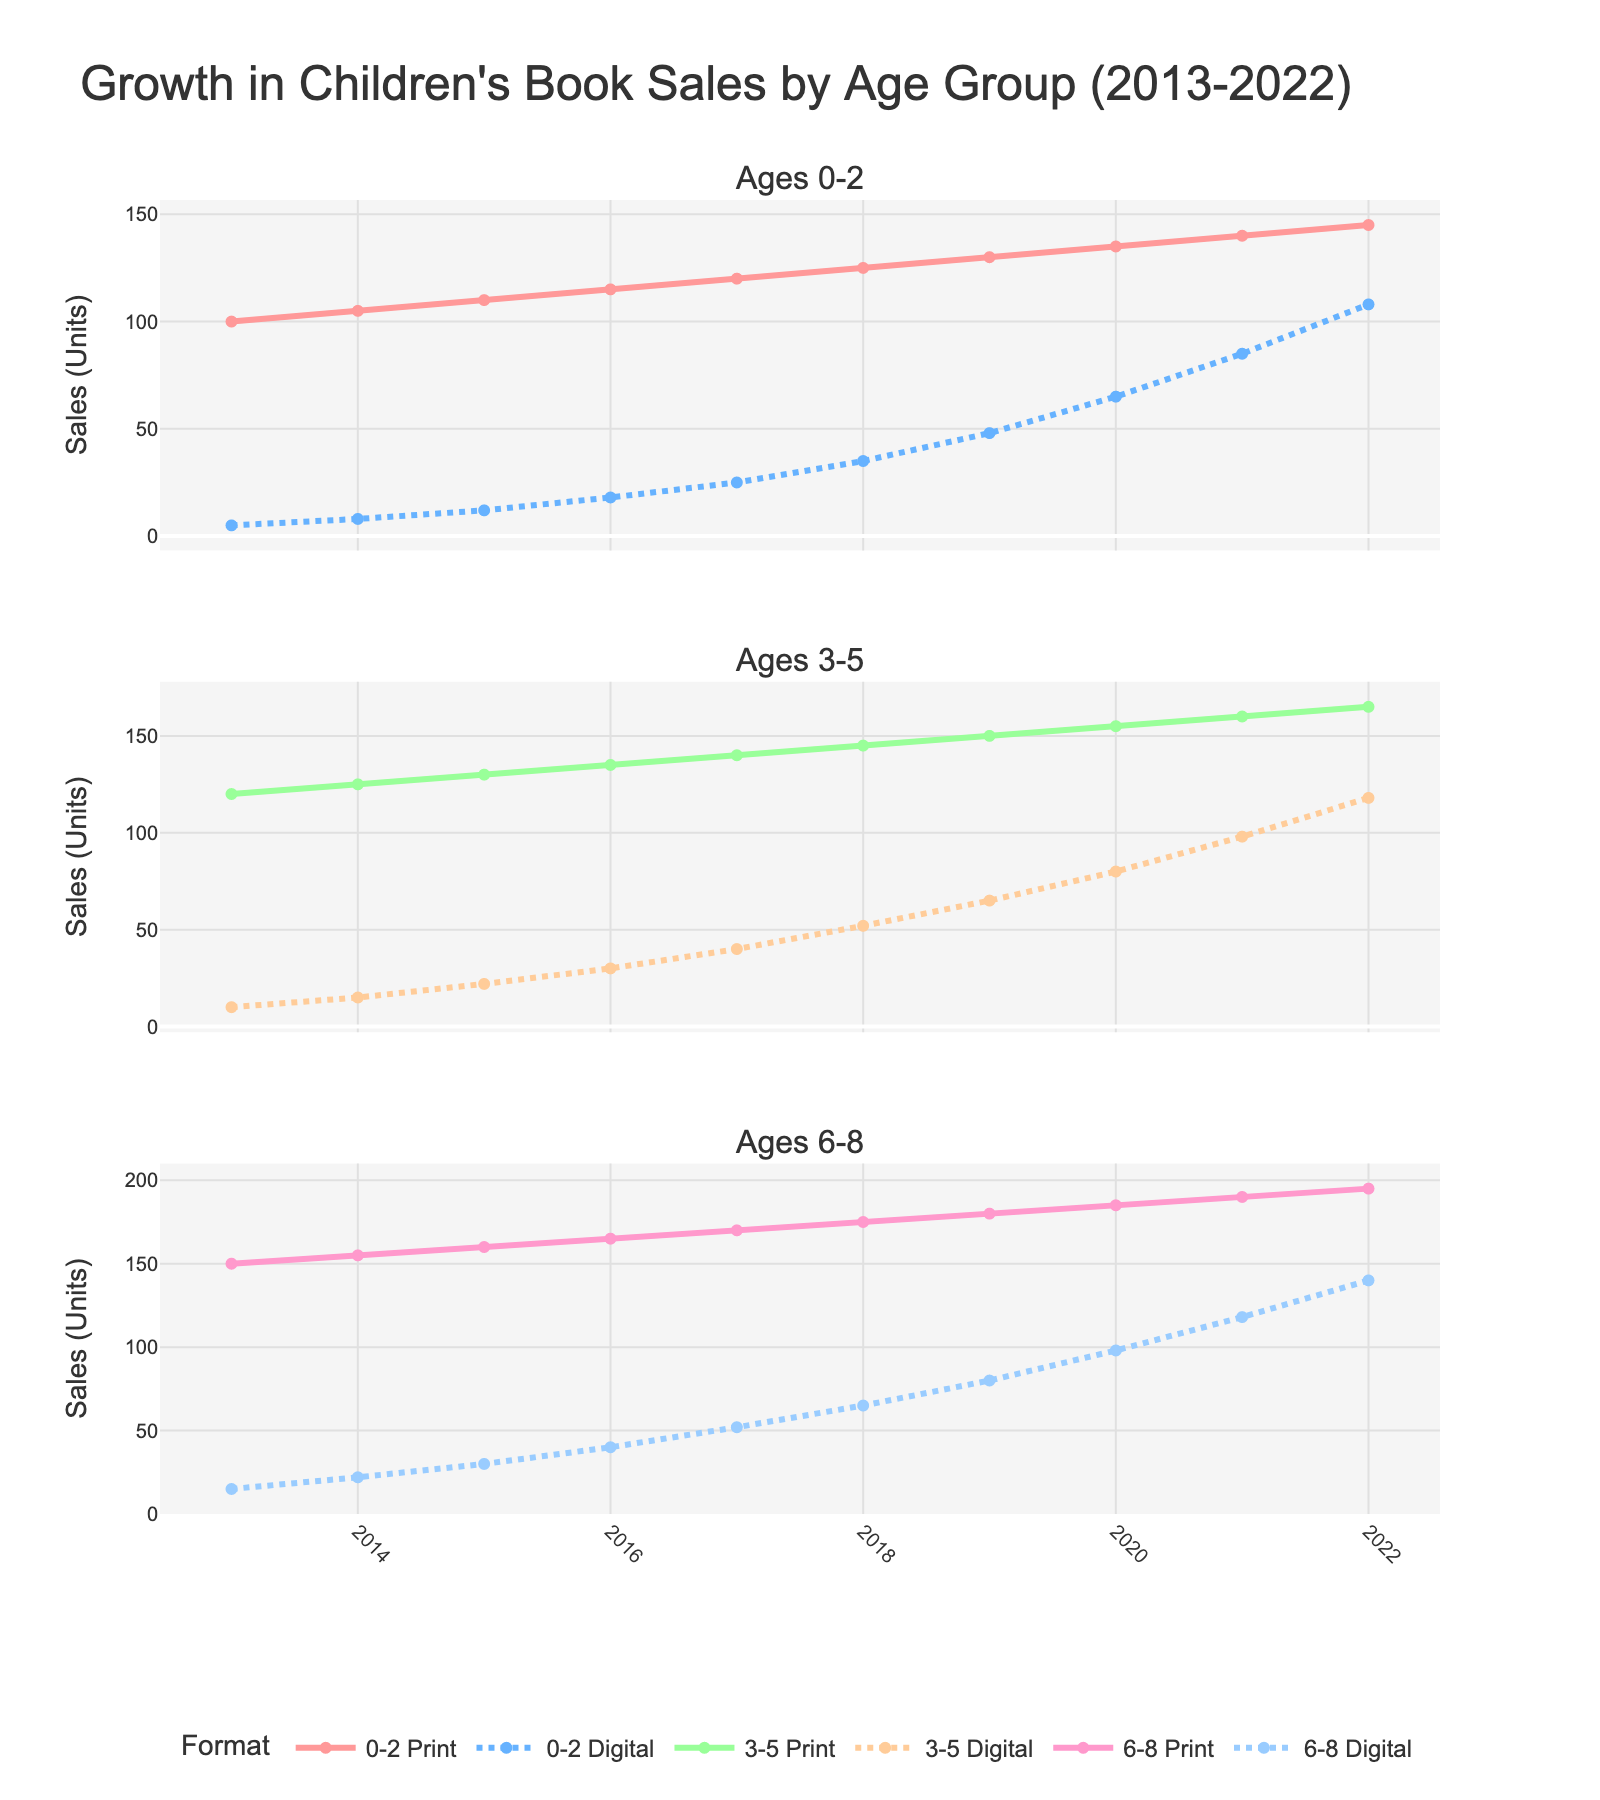What's the difference in print book sales for the 0-2 age group between 2013 and 2022? To find the difference, subtract the sales in 2013 (100 units) from the sales in 2022 (145 units). The calculation is 145 - 100.
Answer: 45 Which year shows the highest digital book sales for the 6-8 age group? Look for the peak value in the 6-8 Digital line. The highest value is 140 units in the year 2022.
Answer: 2022 Compare the print and digital book sales for the 3-5 age group in 2018. Which format had higher sales? In 2018, the print sales are 145 units while the digital sales are 52 units. Print sales are higher.
Answer: Print During which year did the 6-8 digital book sales surpass the 0-2 print book sales? Look for the first year where the number of 6-8 Digital sales exceeds 0-2 Print sales. 6-8 Digital surpasses 0-2 Print in 2022 with 140 units versus 145 units.
Answer: 2022 What is the average growth in print book sales per year for the 3-5 age group from 2013 to 2022? Calculate the total growth (165 in 2022 - 120 in 2013 = 45) then divide by the number of years (2022 - 2013 = 9). The average growth per year is 45 / 9.
Answer: 5 How does the trend of digital book sales for the 0-2 age group compare to the 3-5 age group over the decade? Compare the slopes of both lines from 2013 to 2022. The 0-2 age group starts at 5 and ends at 108, and the 3-5 age group starts at 10 and ends at 118. While both have increased significantly, the 3-5 age group shows slightly higher digital sales.
Answer: 3-5 has higher sales Which age group had the most consistent growth in print book sales over the past decade? Identify the trend lines for each age group in print format. The sales for all age groups increased consistently, but calculating the standard deviation or visual inspection of the trend lines can confirm. Sales for all groups seem quite consistent, so this may require more detailed analysis.
Answer: Consistent for all Did digital book sales ever exceed print book sales for any age group within a single year? By comparing all yearly values for digital and print sales across all age groups, we see that digital sales never exceeded print sales in any given year.
Answer: No What year did the 6-8 age group see the sharpest increase in digital book sales? Look for the steepest slope in the 6-8 Digital trend. The greatest increase is seen between 2017 (52 units) and 2018 (65 units), an increase of 13 units.
Answer: 2018 What's the total sum of print book sales for the 0-2, 3-5, and 6-8 age groups in 2020? Add the print book sales for 0-2 (135), 3-5 (155), and 6-8 (185) in 2020. The total is 135 + 155 + 185.
Answer: 475 